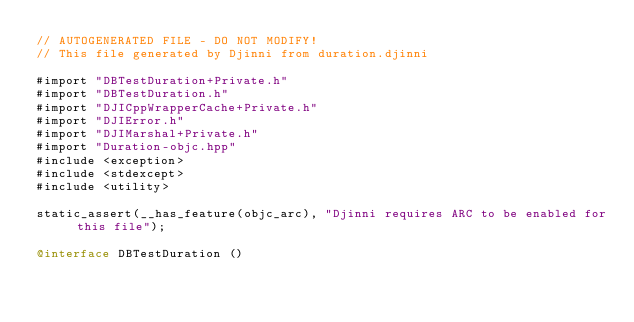<code> <loc_0><loc_0><loc_500><loc_500><_ObjectiveC_>// AUTOGENERATED FILE - DO NOT MODIFY!
// This file generated by Djinni from duration.djinni

#import "DBTestDuration+Private.h"
#import "DBTestDuration.h"
#import "DJICppWrapperCache+Private.h"
#import "DJIError.h"
#import "DJIMarshal+Private.h"
#import "Duration-objc.hpp"
#include <exception>
#include <stdexcept>
#include <utility>

static_assert(__has_feature(objc_arc), "Djinni requires ARC to be enabled for this file");

@interface DBTestDuration ()
</code> 